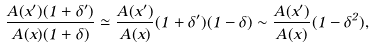<formula> <loc_0><loc_0><loc_500><loc_500>\frac { A ( x ^ { \prime } ) ( 1 + \delta ^ { \prime } ) } { A ( x ) ( 1 + \delta ) } \simeq \frac { A ( x ^ { \prime } ) } { A ( x ) } ( 1 + \delta ^ { \prime } ) ( 1 - \delta ) \sim \frac { A ( x ^ { \prime } ) } { A ( x ) } ( 1 - \delta ^ { 2 } ) ,</formula> 